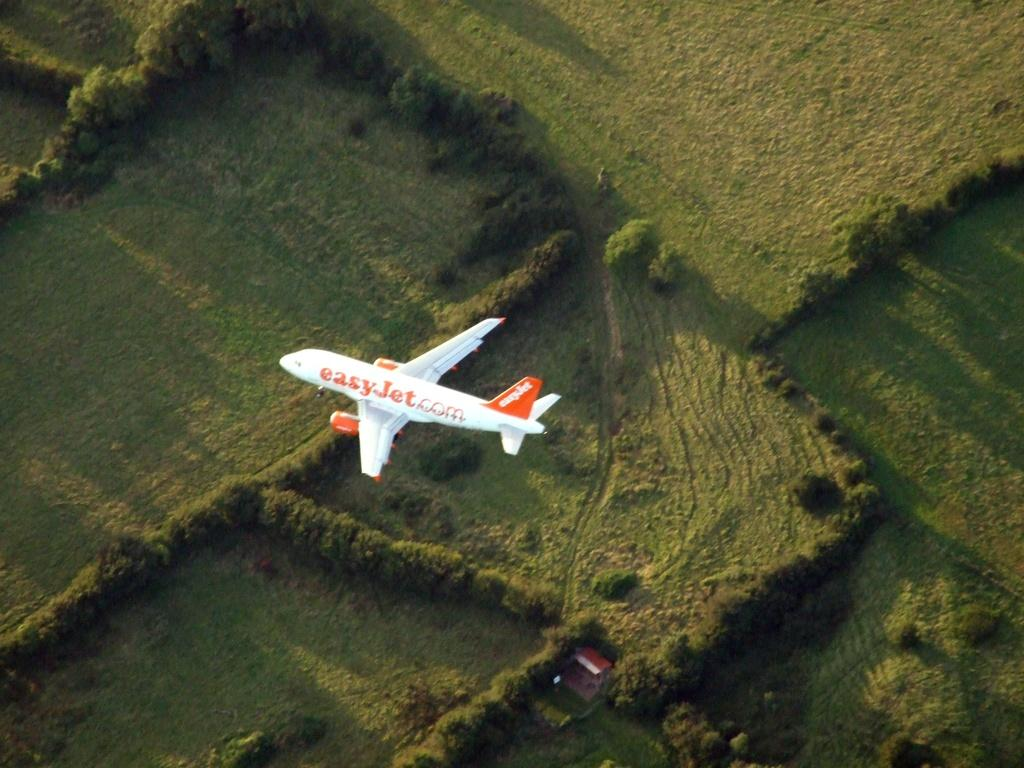<image>
Relay a brief, clear account of the picture shown. An Easy Jet flies in the air above grassy green fields. 